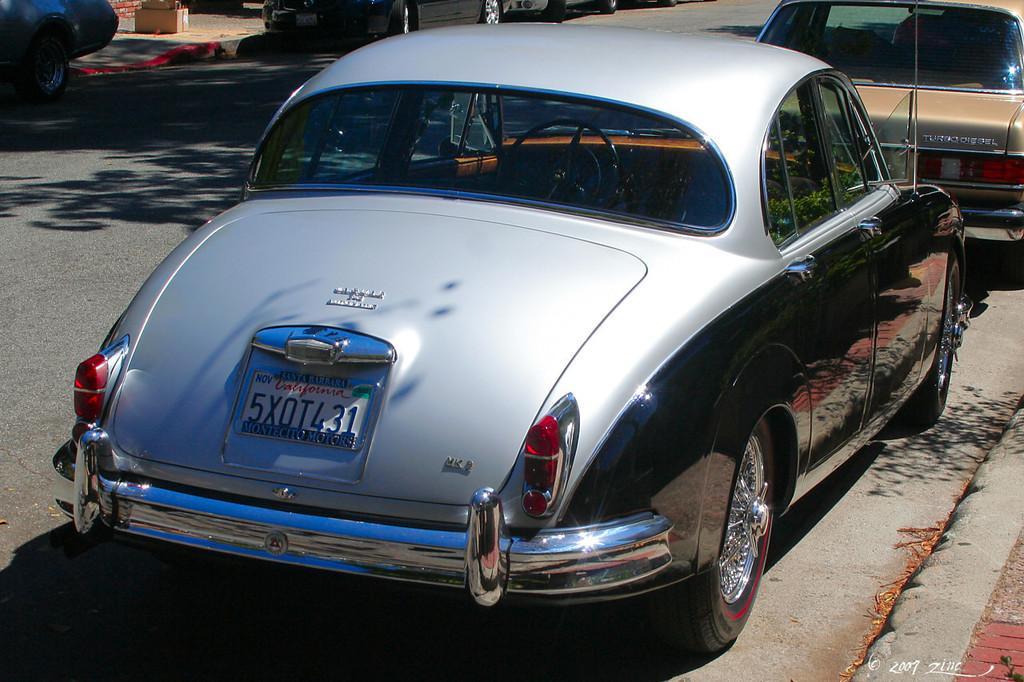Describe this image in one or two sentences. In this picture we can observe a car which is in black and silver color on the road. We can observe some cars parked on the road. On the right side there is a white color watermark in this picture. 